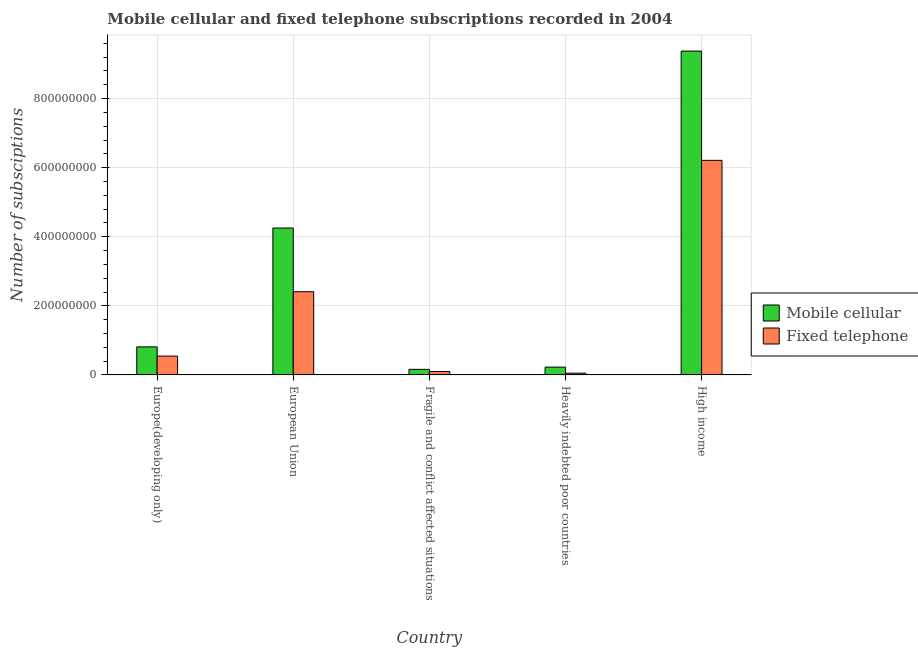How many different coloured bars are there?
Offer a very short reply. 2. Are the number of bars on each tick of the X-axis equal?
Provide a succinct answer. Yes. What is the label of the 1st group of bars from the left?
Your answer should be compact. Europe(developing only). What is the number of fixed telephone subscriptions in Europe(developing only)?
Your answer should be very brief. 5.45e+07. Across all countries, what is the maximum number of fixed telephone subscriptions?
Provide a short and direct response. 6.21e+08. Across all countries, what is the minimum number of mobile cellular subscriptions?
Your answer should be compact. 1.61e+07. In which country was the number of mobile cellular subscriptions maximum?
Keep it short and to the point. High income. In which country was the number of fixed telephone subscriptions minimum?
Provide a succinct answer. Heavily indebted poor countries. What is the total number of fixed telephone subscriptions in the graph?
Provide a succinct answer. 9.32e+08. What is the difference between the number of fixed telephone subscriptions in Europe(developing only) and that in High income?
Your response must be concise. -5.67e+08. What is the difference between the number of fixed telephone subscriptions in High income and the number of mobile cellular subscriptions in Europe(developing only)?
Offer a terse response. 5.40e+08. What is the average number of mobile cellular subscriptions per country?
Make the answer very short. 2.97e+08. What is the difference between the number of fixed telephone subscriptions and number of mobile cellular subscriptions in Europe(developing only)?
Offer a terse response. -2.67e+07. In how many countries, is the number of mobile cellular subscriptions greater than 920000000 ?
Your answer should be very brief. 1. What is the ratio of the number of mobile cellular subscriptions in European Union to that in Fragile and conflict affected situations?
Offer a terse response. 26.43. Is the number of fixed telephone subscriptions in Europe(developing only) less than that in Heavily indebted poor countries?
Keep it short and to the point. No. Is the difference between the number of mobile cellular subscriptions in European Union and Heavily indebted poor countries greater than the difference between the number of fixed telephone subscriptions in European Union and Heavily indebted poor countries?
Offer a terse response. Yes. What is the difference between the highest and the second highest number of fixed telephone subscriptions?
Make the answer very short. 3.80e+08. What is the difference between the highest and the lowest number of fixed telephone subscriptions?
Your response must be concise. 6.16e+08. What does the 1st bar from the left in Heavily indebted poor countries represents?
Give a very brief answer. Mobile cellular. What does the 2nd bar from the right in European Union represents?
Your answer should be very brief. Mobile cellular. Are all the bars in the graph horizontal?
Ensure brevity in your answer.  No. What is the difference between two consecutive major ticks on the Y-axis?
Your answer should be very brief. 2.00e+08. Are the values on the major ticks of Y-axis written in scientific E-notation?
Your response must be concise. No. Where does the legend appear in the graph?
Your answer should be compact. Center right. How many legend labels are there?
Ensure brevity in your answer.  2. How are the legend labels stacked?
Keep it short and to the point. Vertical. What is the title of the graph?
Provide a succinct answer. Mobile cellular and fixed telephone subscriptions recorded in 2004. What is the label or title of the X-axis?
Your answer should be very brief. Country. What is the label or title of the Y-axis?
Your answer should be very brief. Number of subsciptions. What is the Number of subsciptions of Mobile cellular in Europe(developing only)?
Offer a very short reply. 8.12e+07. What is the Number of subsciptions in Fixed telephone in Europe(developing only)?
Your response must be concise. 5.45e+07. What is the Number of subsciptions in Mobile cellular in European Union?
Your answer should be compact. 4.25e+08. What is the Number of subsciptions of Fixed telephone in European Union?
Offer a very short reply. 2.41e+08. What is the Number of subsciptions of Mobile cellular in Fragile and conflict affected situations?
Provide a succinct answer. 1.61e+07. What is the Number of subsciptions of Fixed telephone in Fragile and conflict affected situations?
Your answer should be very brief. 9.83e+06. What is the Number of subsciptions of Mobile cellular in Heavily indebted poor countries?
Keep it short and to the point. 2.26e+07. What is the Number of subsciptions of Fixed telephone in Heavily indebted poor countries?
Offer a terse response. 5.16e+06. What is the Number of subsciptions in Mobile cellular in High income?
Offer a very short reply. 9.38e+08. What is the Number of subsciptions in Fixed telephone in High income?
Offer a terse response. 6.21e+08. Across all countries, what is the maximum Number of subsciptions in Mobile cellular?
Provide a succinct answer. 9.38e+08. Across all countries, what is the maximum Number of subsciptions in Fixed telephone?
Provide a succinct answer. 6.21e+08. Across all countries, what is the minimum Number of subsciptions of Mobile cellular?
Give a very brief answer. 1.61e+07. Across all countries, what is the minimum Number of subsciptions of Fixed telephone?
Offer a very short reply. 5.16e+06. What is the total Number of subsciptions of Mobile cellular in the graph?
Provide a succinct answer. 1.48e+09. What is the total Number of subsciptions in Fixed telephone in the graph?
Give a very brief answer. 9.32e+08. What is the difference between the Number of subsciptions of Mobile cellular in Europe(developing only) and that in European Union?
Provide a succinct answer. -3.44e+08. What is the difference between the Number of subsciptions of Fixed telephone in Europe(developing only) and that in European Union?
Ensure brevity in your answer.  -1.86e+08. What is the difference between the Number of subsciptions in Mobile cellular in Europe(developing only) and that in Fragile and conflict affected situations?
Your response must be concise. 6.51e+07. What is the difference between the Number of subsciptions of Fixed telephone in Europe(developing only) and that in Fragile and conflict affected situations?
Your answer should be very brief. 4.47e+07. What is the difference between the Number of subsciptions in Mobile cellular in Europe(developing only) and that in Heavily indebted poor countries?
Give a very brief answer. 5.87e+07. What is the difference between the Number of subsciptions of Fixed telephone in Europe(developing only) and that in Heavily indebted poor countries?
Give a very brief answer. 4.94e+07. What is the difference between the Number of subsciptions of Mobile cellular in Europe(developing only) and that in High income?
Keep it short and to the point. -8.56e+08. What is the difference between the Number of subsciptions of Fixed telephone in Europe(developing only) and that in High income?
Keep it short and to the point. -5.67e+08. What is the difference between the Number of subsciptions of Mobile cellular in European Union and that in Fragile and conflict affected situations?
Make the answer very short. 4.09e+08. What is the difference between the Number of subsciptions of Fixed telephone in European Union and that in Fragile and conflict affected situations?
Your answer should be very brief. 2.31e+08. What is the difference between the Number of subsciptions of Mobile cellular in European Union and that in Heavily indebted poor countries?
Offer a terse response. 4.03e+08. What is the difference between the Number of subsciptions of Fixed telephone in European Union and that in Heavily indebted poor countries?
Your answer should be very brief. 2.36e+08. What is the difference between the Number of subsciptions in Mobile cellular in European Union and that in High income?
Your response must be concise. -5.12e+08. What is the difference between the Number of subsciptions of Fixed telephone in European Union and that in High income?
Your answer should be very brief. -3.80e+08. What is the difference between the Number of subsciptions of Mobile cellular in Fragile and conflict affected situations and that in Heavily indebted poor countries?
Provide a succinct answer. -6.47e+06. What is the difference between the Number of subsciptions of Fixed telephone in Fragile and conflict affected situations and that in Heavily indebted poor countries?
Offer a terse response. 4.67e+06. What is the difference between the Number of subsciptions in Mobile cellular in Fragile and conflict affected situations and that in High income?
Make the answer very short. -9.22e+08. What is the difference between the Number of subsciptions of Fixed telephone in Fragile and conflict affected situations and that in High income?
Your answer should be compact. -6.11e+08. What is the difference between the Number of subsciptions of Mobile cellular in Heavily indebted poor countries and that in High income?
Provide a short and direct response. -9.15e+08. What is the difference between the Number of subsciptions in Fixed telephone in Heavily indebted poor countries and that in High income?
Offer a very short reply. -6.16e+08. What is the difference between the Number of subsciptions of Mobile cellular in Europe(developing only) and the Number of subsciptions of Fixed telephone in European Union?
Offer a terse response. -1.60e+08. What is the difference between the Number of subsciptions in Mobile cellular in Europe(developing only) and the Number of subsciptions in Fixed telephone in Fragile and conflict affected situations?
Give a very brief answer. 7.14e+07. What is the difference between the Number of subsciptions in Mobile cellular in Europe(developing only) and the Number of subsciptions in Fixed telephone in Heavily indebted poor countries?
Offer a very short reply. 7.61e+07. What is the difference between the Number of subsciptions in Mobile cellular in Europe(developing only) and the Number of subsciptions in Fixed telephone in High income?
Your answer should be very brief. -5.40e+08. What is the difference between the Number of subsciptions in Mobile cellular in European Union and the Number of subsciptions in Fixed telephone in Fragile and conflict affected situations?
Keep it short and to the point. 4.16e+08. What is the difference between the Number of subsciptions in Mobile cellular in European Union and the Number of subsciptions in Fixed telephone in Heavily indebted poor countries?
Your answer should be very brief. 4.20e+08. What is the difference between the Number of subsciptions of Mobile cellular in European Union and the Number of subsciptions of Fixed telephone in High income?
Provide a succinct answer. -1.96e+08. What is the difference between the Number of subsciptions in Mobile cellular in Fragile and conflict affected situations and the Number of subsciptions in Fixed telephone in Heavily indebted poor countries?
Offer a terse response. 1.09e+07. What is the difference between the Number of subsciptions in Mobile cellular in Fragile and conflict affected situations and the Number of subsciptions in Fixed telephone in High income?
Ensure brevity in your answer.  -6.05e+08. What is the difference between the Number of subsciptions in Mobile cellular in Heavily indebted poor countries and the Number of subsciptions in Fixed telephone in High income?
Give a very brief answer. -5.99e+08. What is the average Number of subsciptions in Mobile cellular per country?
Provide a short and direct response. 2.97e+08. What is the average Number of subsciptions of Fixed telephone per country?
Provide a short and direct response. 1.86e+08. What is the difference between the Number of subsciptions of Mobile cellular and Number of subsciptions of Fixed telephone in Europe(developing only)?
Your answer should be very brief. 2.67e+07. What is the difference between the Number of subsciptions of Mobile cellular and Number of subsciptions of Fixed telephone in European Union?
Ensure brevity in your answer.  1.84e+08. What is the difference between the Number of subsciptions in Mobile cellular and Number of subsciptions in Fixed telephone in Fragile and conflict affected situations?
Give a very brief answer. 6.27e+06. What is the difference between the Number of subsciptions in Mobile cellular and Number of subsciptions in Fixed telephone in Heavily indebted poor countries?
Offer a terse response. 1.74e+07. What is the difference between the Number of subsciptions in Mobile cellular and Number of subsciptions in Fixed telephone in High income?
Provide a succinct answer. 3.16e+08. What is the ratio of the Number of subsciptions in Mobile cellular in Europe(developing only) to that in European Union?
Ensure brevity in your answer.  0.19. What is the ratio of the Number of subsciptions of Fixed telephone in Europe(developing only) to that in European Union?
Make the answer very short. 0.23. What is the ratio of the Number of subsciptions of Mobile cellular in Europe(developing only) to that in Fragile and conflict affected situations?
Provide a short and direct response. 5.05. What is the ratio of the Number of subsciptions in Fixed telephone in Europe(developing only) to that in Fragile and conflict affected situations?
Ensure brevity in your answer.  5.55. What is the ratio of the Number of subsciptions in Mobile cellular in Europe(developing only) to that in Heavily indebted poor countries?
Provide a succinct answer. 3.6. What is the ratio of the Number of subsciptions of Fixed telephone in Europe(developing only) to that in Heavily indebted poor countries?
Your answer should be compact. 10.58. What is the ratio of the Number of subsciptions in Mobile cellular in Europe(developing only) to that in High income?
Keep it short and to the point. 0.09. What is the ratio of the Number of subsciptions in Fixed telephone in Europe(developing only) to that in High income?
Provide a succinct answer. 0.09. What is the ratio of the Number of subsciptions of Mobile cellular in European Union to that in Fragile and conflict affected situations?
Make the answer very short. 26.43. What is the ratio of the Number of subsciptions of Fixed telephone in European Union to that in Fragile and conflict affected situations?
Provide a succinct answer. 24.51. What is the ratio of the Number of subsciptions of Mobile cellular in European Union to that in Heavily indebted poor countries?
Provide a short and direct response. 18.85. What is the ratio of the Number of subsciptions in Fixed telephone in European Union to that in Heavily indebted poor countries?
Your answer should be compact. 46.73. What is the ratio of the Number of subsciptions in Mobile cellular in European Union to that in High income?
Offer a terse response. 0.45. What is the ratio of the Number of subsciptions in Fixed telephone in European Union to that in High income?
Ensure brevity in your answer.  0.39. What is the ratio of the Number of subsciptions of Mobile cellular in Fragile and conflict affected situations to that in Heavily indebted poor countries?
Ensure brevity in your answer.  0.71. What is the ratio of the Number of subsciptions of Fixed telephone in Fragile and conflict affected situations to that in Heavily indebted poor countries?
Ensure brevity in your answer.  1.91. What is the ratio of the Number of subsciptions of Mobile cellular in Fragile and conflict affected situations to that in High income?
Your answer should be compact. 0.02. What is the ratio of the Number of subsciptions in Fixed telephone in Fragile and conflict affected situations to that in High income?
Offer a terse response. 0.02. What is the ratio of the Number of subsciptions in Mobile cellular in Heavily indebted poor countries to that in High income?
Ensure brevity in your answer.  0.02. What is the ratio of the Number of subsciptions of Fixed telephone in Heavily indebted poor countries to that in High income?
Provide a succinct answer. 0.01. What is the difference between the highest and the second highest Number of subsciptions of Mobile cellular?
Provide a short and direct response. 5.12e+08. What is the difference between the highest and the second highest Number of subsciptions in Fixed telephone?
Give a very brief answer. 3.80e+08. What is the difference between the highest and the lowest Number of subsciptions of Mobile cellular?
Your answer should be very brief. 9.22e+08. What is the difference between the highest and the lowest Number of subsciptions of Fixed telephone?
Give a very brief answer. 6.16e+08. 